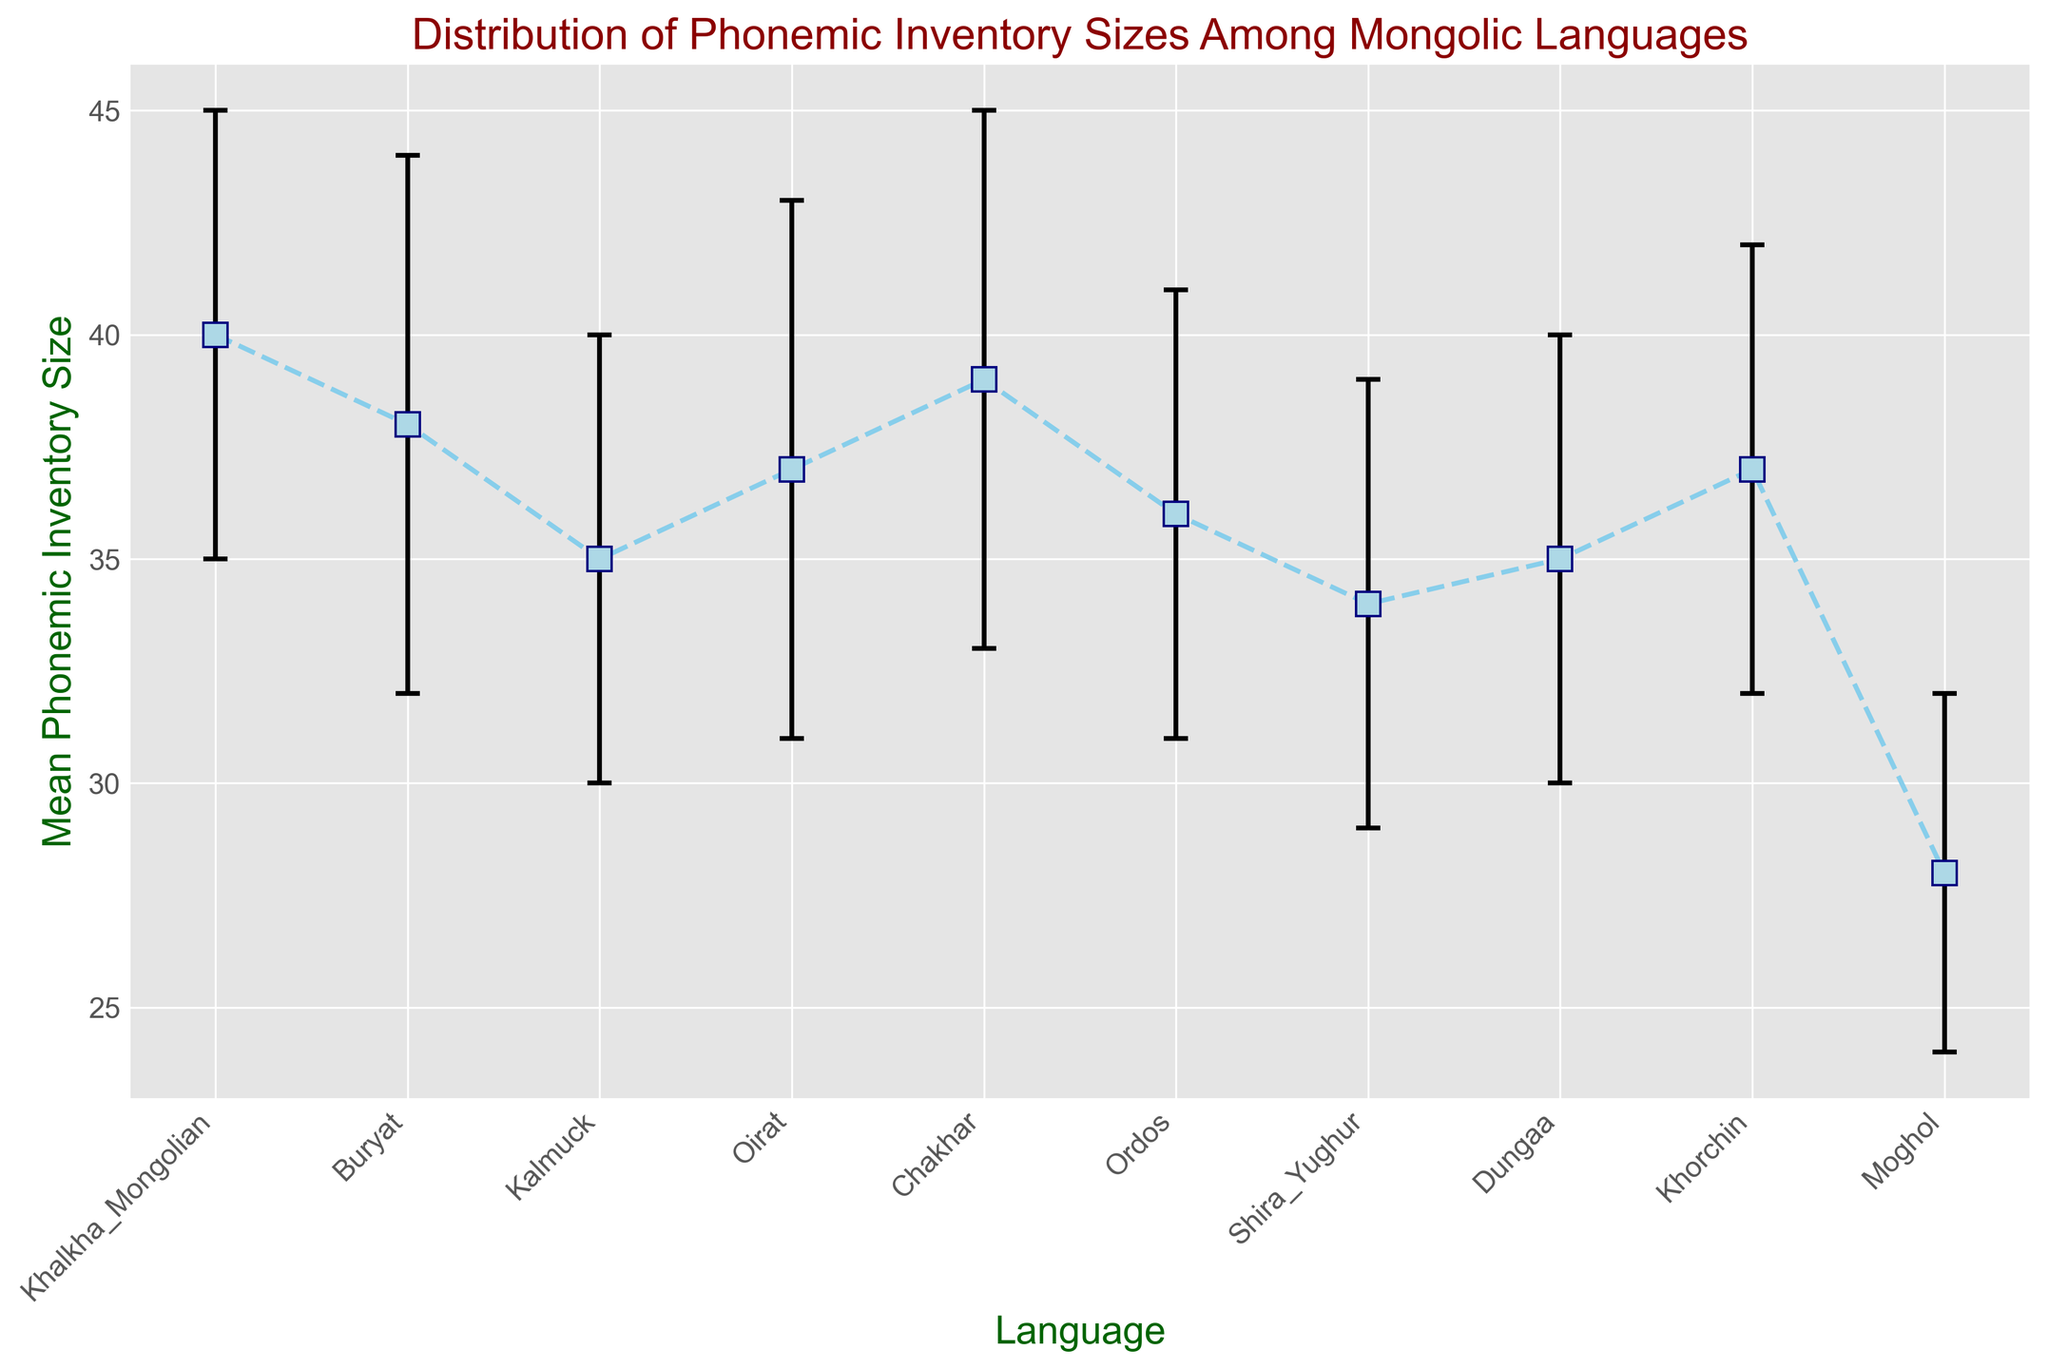What's the language with the highest mean phonemic inventory size? The language with the highest mean phonemic inventory size can be identified directly from the y-values of the plot. The language with the highest value is seen at 40 units.
Answer: Khalkha Mongolian Which language has the smallest confidence interval (range between the upper and lower CI)? To find the smallest confidence interval, calculate the width of the confidence interval for each language by subtracting the lower CI from the upper CI and compare them. The smallest difference is found in Moghol (32 - 24 = 8).
Answer: Moghol How many languages have a mean phonemic inventory size greater than 35? Count the number of bars or points representing languages where the mean phonemic inventory size exceeds 35. Khalkha Mongolian, Buryat, Oirat, Chakhar, Ordos, and Khorchin have mean sizes greater than 35.
Answer: 6 What is the range of the phonemic inventory size for Dungaa? Subtract the lower CI value from the upper CI value for Dungaa. The range is (40 - 30).
Answer: 10 Which two languages have the closest mean phonemic inventory sizes? Compare the mean phonemic inventory sizes to find the smallest difference. Buryat (38) and Chakhar (39) are the closest with a difference of 1.
Answer: Buryat and Chakhar What is the difference in the mean phonemic inventory size between Khalkha Mongolian and Moghol? Subtract the mean phonemic inventory size of Moghol from Khalkha Mongolian. The difference is (40 - 28).
Answer: 12 Which language has an upper confidence interval of exactly 41? Locate the language whose upper CI value is 41. This is Ordos.
Answer: Ordos Which language has the widest confidence interval, and what is its width? Calculate the width for all languages and identify the largest interval. Buryat has the widest interval from 32 to 44, making the width (44 - 32).
Answer: Buryat, 12 Do any languages have non-overlapping confidence intervals for their phonemic inventory sizes? Look at the confidence intervals for each language and check for overlaps. Moghol (24-32) does not overlap with any other language's intervals.
Answer: Moghol 